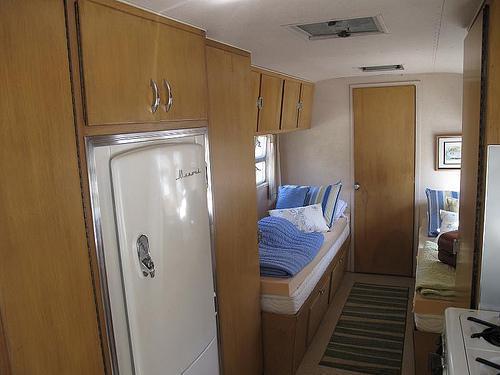How many beds are there?
Give a very brief answer. 2. 